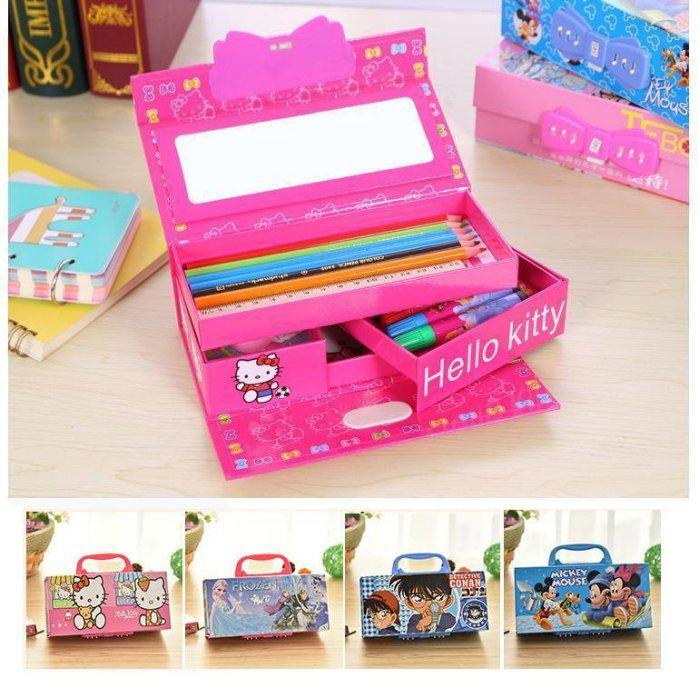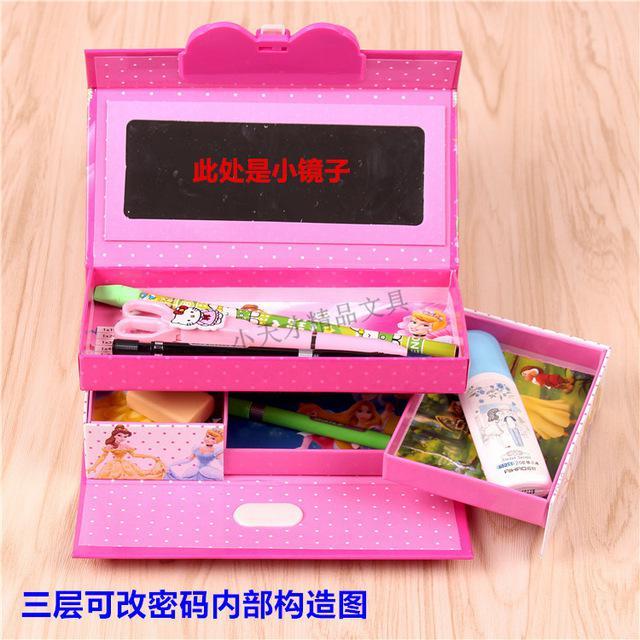The first image is the image on the left, the second image is the image on the right. For the images displayed, is the sentence "Both of the cases is opened to reveal their items." factually correct? Answer yes or no. Yes. The first image is the image on the left, the second image is the image on the right. For the images displayed, is the sentence "The right image contains a pencil holder that has a small drawer in the middle that is pulled out." factually correct? Answer yes or no. Yes. 